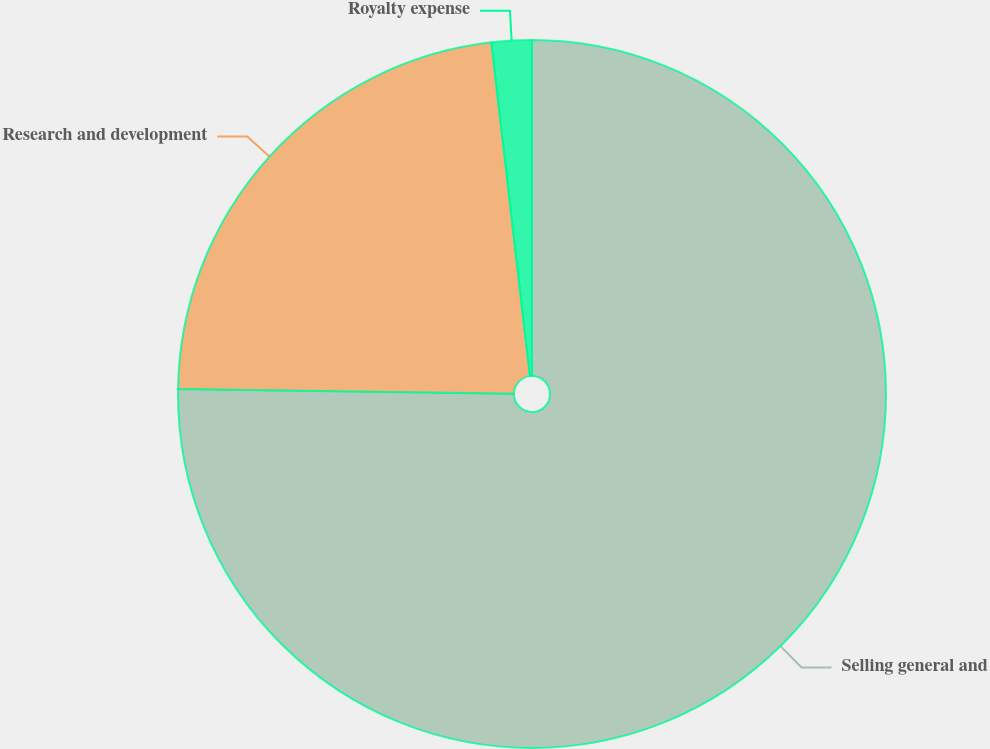<chart> <loc_0><loc_0><loc_500><loc_500><pie_chart><fcel>Selling general and<fcel>Research and development<fcel>Royalty expense<nl><fcel>75.23%<fcel>22.94%<fcel>1.83%<nl></chart> 